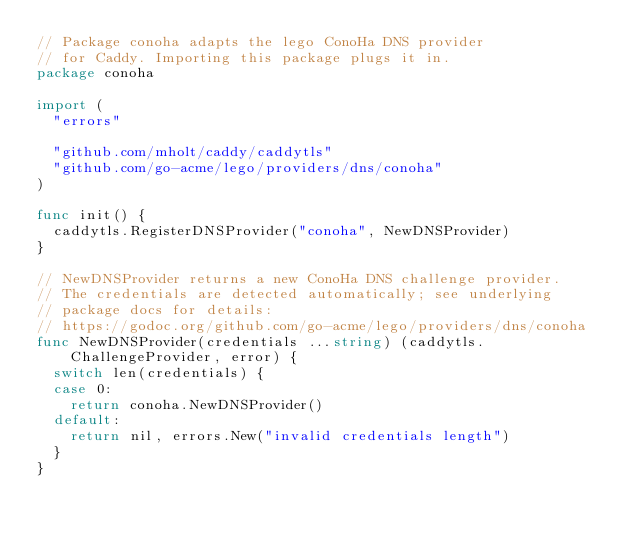<code> <loc_0><loc_0><loc_500><loc_500><_Go_>// Package conoha adapts the lego ConoHa DNS provider
// for Caddy. Importing this package plugs it in.
package conoha

import (
	"errors"

	"github.com/mholt/caddy/caddytls"
	"github.com/go-acme/lego/providers/dns/conoha"
)

func init() {
	caddytls.RegisterDNSProvider("conoha", NewDNSProvider)
}

// NewDNSProvider returns a new ConoHa DNS challenge provider.
// The credentials are detected automatically; see underlying
// package docs for details:
// https://godoc.org/github.com/go-acme/lego/providers/dns/conoha
func NewDNSProvider(credentials ...string) (caddytls.ChallengeProvider, error) {
	switch len(credentials) {
	case 0:
		return conoha.NewDNSProvider()
	default:
		return nil, errors.New("invalid credentials length")
	}
}
</code> 